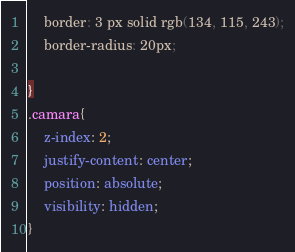<code> <loc_0><loc_0><loc_500><loc_500><_CSS_>    border: 3 px solid rgb(134, 115, 243);
    border-radius: 20px;  

}
.camara{
    z-index: 2;
    justify-content: center;
    position: absolute;
    visibility: hidden;
}

</code> 